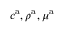Convert formula to latex. <formula><loc_0><loc_0><loc_500><loc_500>c ^ { a } , \rho ^ { a } , \mu ^ { a }</formula> 